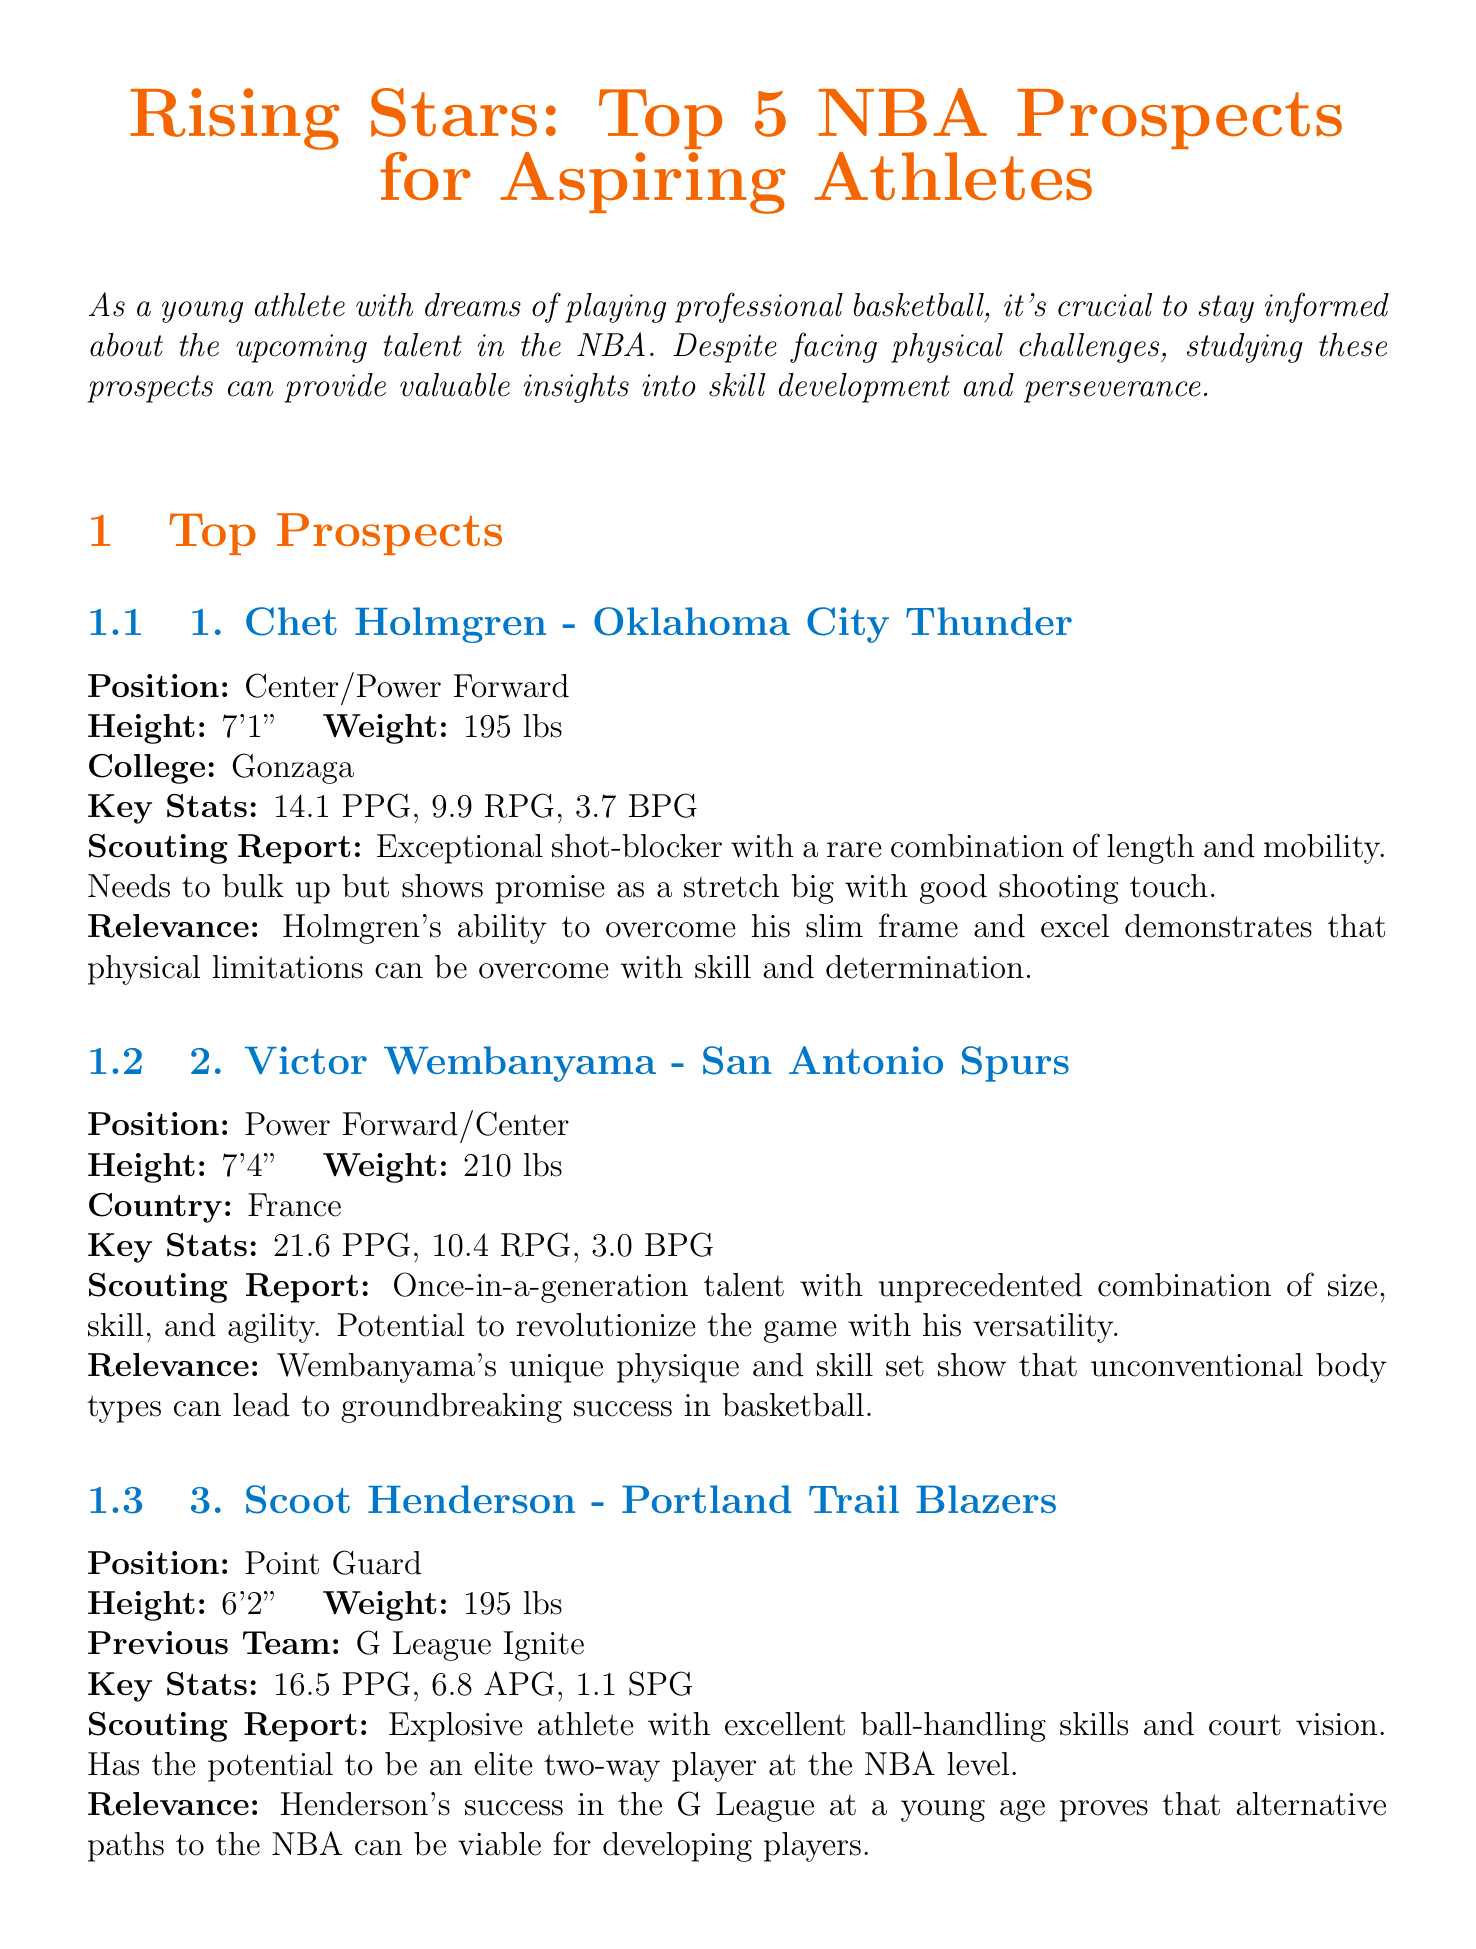What is the title of the newsletter? The title is the main heading that indicates the topic of the document.
Answer: Rising Stars: Top 5 NBA Prospects for Aspiring Athletes Who is the first prospect mentioned? The first prospect is the player listed at the top in the newsletter.
Answer: Chet Holmgren What is Victor Wembanyama's points per game? Points per game is a key statistic that indicates the player's scoring average during games.
Answer: 21.6 How tall is Amen Thompson? The height is a physical measurement included in the player's profile section.
Answer: 6'7" Which team does Ausar Thompson play for? The team is the organization the player is associated with during the current season.
Answer: Detroit Pistons What significant ability does Scoot Henderson possess according to the scouting report? The scouting report typically highlights key skills or attributes of the player.
Answer: Excellent ball-handling skills What do Holmgren and Wembanyama have in common regarding their physical attributes? This question requires comparing both players' physical descriptions for similarities.
Answer: Both are tall centers What is the relevance of Thompson's development through Overtime Elite? The relevance section explains why this player's journey is important to aspiring athletes.
Answer: Innovative ways to prepare for a professional career How many rebounds per game does Ausar Thompson average? Rebounds per game is a statistical measure reflecting the player's performance in recovering the ball.
Answer: 7.1 